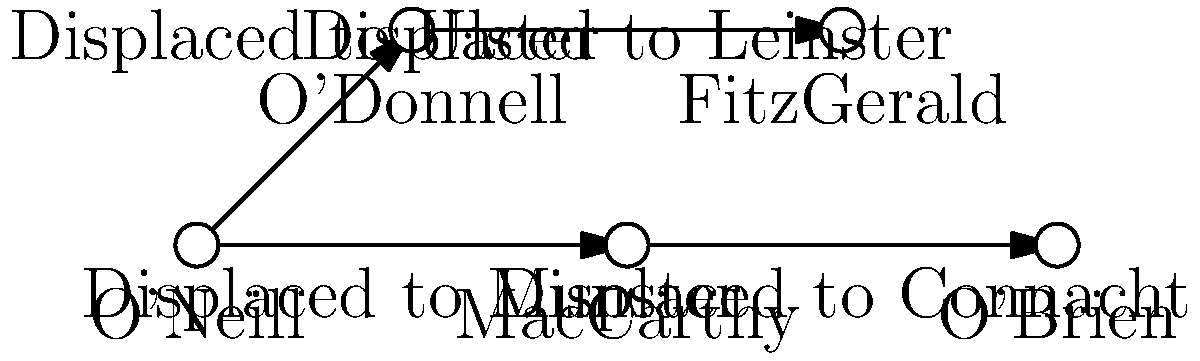Based on the genealogical network diagram showing the displacement of Irish families due to colonial policies, which family appears to have been most influential in terms of its connections and subsequent displacements? To determine the most influential family in terms of connections and subsequent displacements, we need to analyze the network diagram step-by-step:

1. Identify the families in the network:
   O'Neill, O'Donnell, MacCarthy, FitzGerald, and O'Brien

2. Analyze the connections:
   - O'Neill is connected to both O'Donnell and MacCarthy
   - O'Donnell is connected to FitzGerald
   - MacCarthy is connected to O'Brien

3. Count the number of direct connections:
   - O'Neill: 2 connections
   - O'Donnell: 1 connection
   - MacCarthy: 1 connection
   - FitzGerald: 0 connections (only receiving)
   - O'Brien: 0 connections (only receiving)

4. Analyze the displacements:
   - O'Neill's connections led to displacements in Ulster and Munster
   - O'Donnell's connection led to a displacement in Leinster
   - MacCarthy's connection led to a displacement in Connacht

5. Evaluate the influence:
   The O'Neill family has the most connections (2) and its displacements affect two provinces (Ulster and Munster). This suggests that the O'Neill family had the most far-reaching influence on other families and their subsequent displacements due to colonial policies.

Based on this analysis, the O'Neill family appears to be the most influential in terms of its connections and subsequent displacements in the network.
Answer: O'Neill 